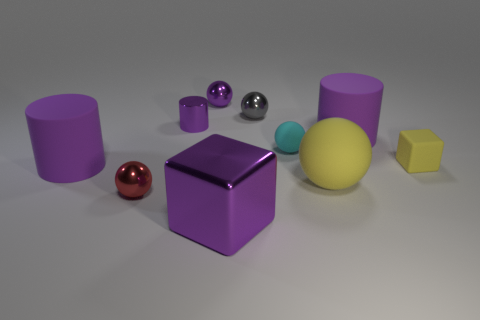What number of other objects are the same material as the tiny cylinder?
Keep it short and to the point. 4. Are there the same number of tiny gray shiny objects that are on the left side of the big shiny thing and metal cubes?
Your response must be concise. No. Do the purple cube and the rubber sphere in front of the small rubber sphere have the same size?
Provide a succinct answer. Yes. What shape is the small gray thing that is in front of the small purple sphere?
Provide a succinct answer. Sphere. Is there a tiny green rubber thing?
Your answer should be compact. No. There is a cyan matte thing that is behind the tiny matte block; is it the same size as the purple object in front of the yellow ball?
Your response must be concise. No. What material is the ball that is both in front of the tiny yellow object and behind the small red metallic thing?
Keep it short and to the point. Rubber. There is a large metal block; what number of purple cylinders are to the left of it?
Your response must be concise. 2. What color is the block that is made of the same material as the yellow sphere?
Provide a succinct answer. Yellow. Is the shape of the red object the same as the small yellow matte object?
Provide a short and direct response. No. 